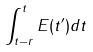Convert formula to latex. <formula><loc_0><loc_0><loc_500><loc_500>\int _ { t - r } ^ { t } E ( t ^ { \prime } ) d t</formula> 